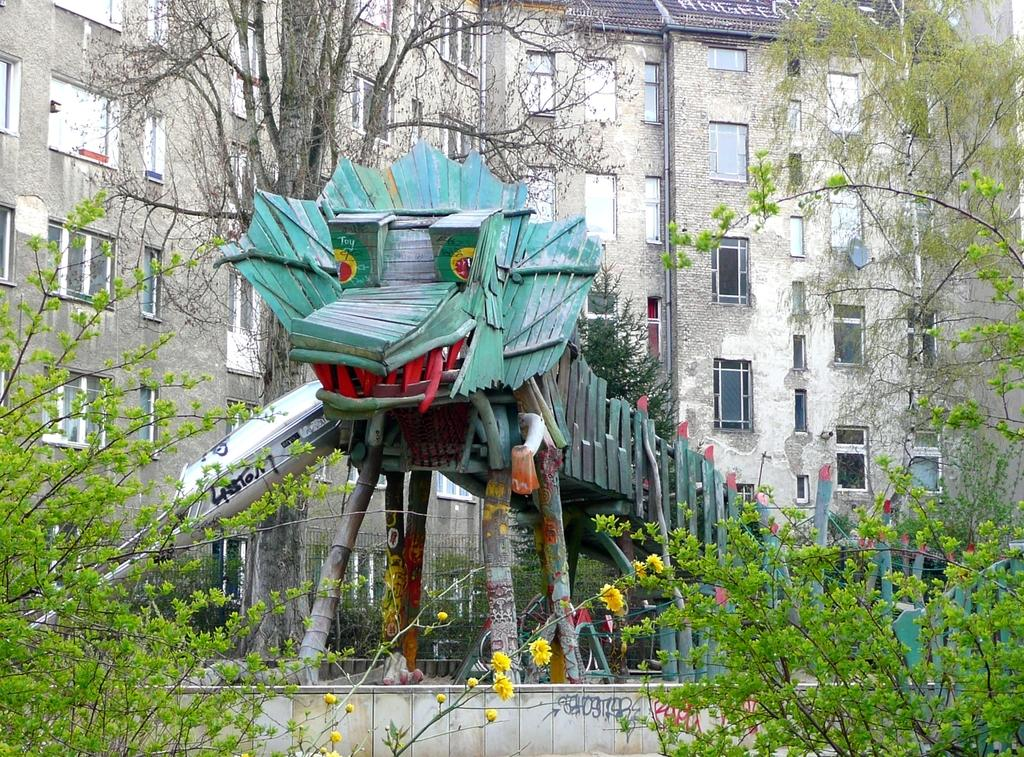What is the main subject in the center of the image? There is a toy in the center of the image. What can be seen in the distance behind the toy? There is a building in the background of the image. What type of natural elements are present in the image? There are plants and trees in the foreground and background of the image. Can you tell me how the sponge is being used in the image? There is no sponge present in the image. Who is the expert in the image? There is no expert depicted in the image. 